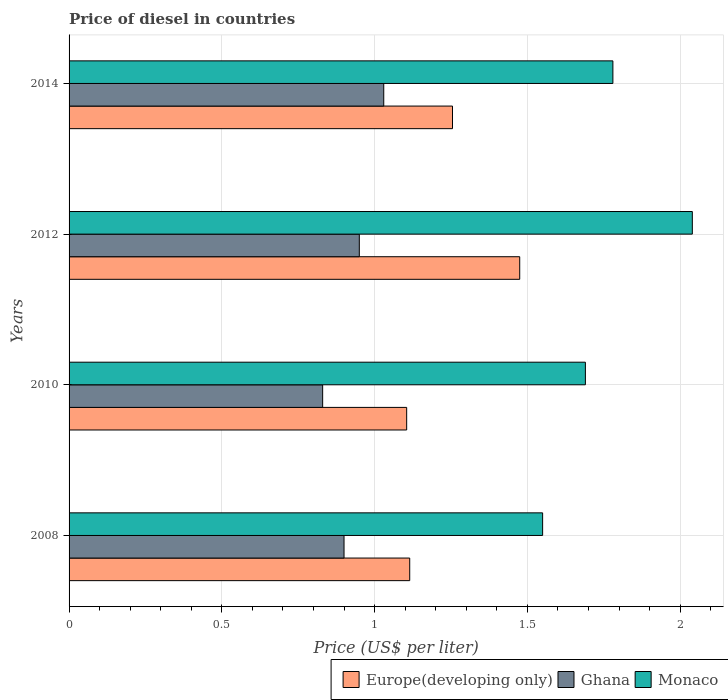How many bars are there on the 2nd tick from the bottom?
Make the answer very short. 3. What is the label of the 3rd group of bars from the top?
Keep it short and to the point. 2010. In how many cases, is the number of bars for a given year not equal to the number of legend labels?
Give a very brief answer. 0. What is the price of diesel in Monaco in 2008?
Offer a terse response. 1.55. Across all years, what is the maximum price of diesel in Monaco?
Offer a very short reply. 2.04. Across all years, what is the minimum price of diesel in Ghana?
Your answer should be very brief. 0.83. In which year was the price of diesel in Monaco maximum?
Offer a very short reply. 2012. What is the total price of diesel in Monaco in the graph?
Your answer should be very brief. 7.06. What is the difference between the price of diesel in Europe(developing only) in 2010 and that in 2012?
Offer a very short reply. -0.37. What is the difference between the price of diesel in Ghana in 2008 and the price of diesel in Monaco in 2012?
Provide a succinct answer. -1.14. What is the average price of diesel in Ghana per year?
Provide a short and direct response. 0.93. In the year 2012, what is the difference between the price of diesel in Monaco and price of diesel in Europe(developing only)?
Your answer should be very brief. 0.56. In how many years, is the price of diesel in Europe(developing only) greater than 1.2 US$?
Provide a succinct answer. 2. What is the ratio of the price of diesel in Ghana in 2010 to that in 2012?
Provide a short and direct response. 0.87. Is the price of diesel in Monaco in 2008 less than that in 2012?
Provide a short and direct response. Yes. What is the difference between the highest and the second highest price of diesel in Ghana?
Offer a very short reply. 0.08. What is the difference between the highest and the lowest price of diesel in Monaco?
Provide a succinct answer. 0.49. In how many years, is the price of diesel in Ghana greater than the average price of diesel in Ghana taken over all years?
Keep it short and to the point. 2. Is the sum of the price of diesel in Ghana in 2008 and 2014 greater than the maximum price of diesel in Monaco across all years?
Ensure brevity in your answer.  No. What does the 1st bar from the top in 2008 represents?
Ensure brevity in your answer.  Monaco. What does the 1st bar from the bottom in 2010 represents?
Offer a very short reply. Europe(developing only). How many bars are there?
Keep it short and to the point. 12. Are all the bars in the graph horizontal?
Give a very brief answer. Yes. What is the difference between two consecutive major ticks on the X-axis?
Offer a very short reply. 0.5. Does the graph contain any zero values?
Ensure brevity in your answer.  No. Does the graph contain grids?
Give a very brief answer. Yes. How are the legend labels stacked?
Make the answer very short. Horizontal. What is the title of the graph?
Give a very brief answer. Price of diesel in countries. Does "Somalia" appear as one of the legend labels in the graph?
Give a very brief answer. No. What is the label or title of the X-axis?
Your answer should be compact. Price (US$ per liter). What is the label or title of the Y-axis?
Keep it short and to the point. Years. What is the Price (US$ per liter) in Europe(developing only) in 2008?
Offer a very short reply. 1.11. What is the Price (US$ per liter) of Monaco in 2008?
Provide a short and direct response. 1.55. What is the Price (US$ per liter) of Europe(developing only) in 2010?
Your answer should be very brief. 1.1. What is the Price (US$ per liter) in Ghana in 2010?
Provide a short and direct response. 0.83. What is the Price (US$ per liter) of Monaco in 2010?
Ensure brevity in your answer.  1.69. What is the Price (US$ per liter) of Europe(developing only) in 2012?
Keep it short and to the point. 1.48. What is the Price (US$ per liter) of Ghana in 2012?
Provide a short and direct response. 0.95. What is the Price (US$ per liter) in Monaco in 2012?
Provide a succinct answer. 2.04. What is the Price (US$ per liter) in Europe(developing only) in 2014?
Offer a very short reply. 1.25. What is the Price (US$ per liter) of Monaco in 2014?
Provide a succinct answer. 1.78. Across all years, what is the maximum Price (US$ per liter) in Europe(developing only)?
Your response must be concise. 1.48. Across all years, what is the maximum Price (US$ per liter) in Ghana?
Provide a short and direct response. 1.03. Across all years, what is the maximum Price (US$ per liter) in Monaco?
Offer a very short reply. 2.04. Across all years, what is the minimum Price (US$ per liter) in Europe(developing only)?
Give a very brief answer. 1.1. Across all years, what is the minimum Price (US$ per liter) in Ghana?
Your answer should be very brief. 0.83. Across all years, what is the minimum Price (US$ per liter) in Monaco?
Your response must be concise. 1.55. What is the total Price (US$ per liter) of Europe(developing only) in the graph?
Your answer should be very brief. 4.95. What is the total Price (US$ per liter) of Ghana in the graph?
Offer a very short reply. 3.71. What is the total Price (US$ per liter) of Monaco in the graph?
Make the answer very short. 7.06. What is the difference between the Price (US$ per liter) of Europe(developing only) in 2008 and that in 2010?
Provide a succinct answer. 0.01. What is the difference between the Price (US$ per liter) of Ghana in 2008 and that in 2010?
Make the answer very short. 0.07. What is the difference between the Price (US$ per liter) in Monaco in 2008 and that in 2010?
Ensure brevity in your answer.  -0.14. What is the difference between the Price (US$ per liter) of Europe(developing only) in 2008 and that in 2012?
Give a very brief answer. -0.36. What is the difference between the Price (US$ per liter) in Ghana in 2008 and that in 2012?
Make the answer very short. -0.05. What is the difference between the Price (US$ per liter) of Monaco in 2008 and that in 2012?
Make the answer very short. -0.49. What is the difference between the Price (US$ per liter) in Europe(developing only) in 2008 and that in 2014?
Your answer should be compact. -0.14. What is the difference between the Price (US$ per liter) of Ghana in 2008 and that in 2014?
Give a very brief answer. -0.13. What is the difference between the Price (US$ per liter) in Monaco in 2008 and that in 2014?
Keep it short and to the point. -0.23. What is the difference between the Price (US$ per liter) in Europe(developing only) in 2010 and that in 2012?
Offer a terse response. -0.37. What is the difference between the Price (US$ per liter) in Ghana in 2010 and that in 2012?
Offer a very short reply. -0.12. What is the difference between the Price (US$ per liter) of Monaco in 2010 and that in 2012?
Make the answer very short. -0.35. What is the difference between the Price (US$ per liter) in Europe(developing only) in 2010 and that in 2014?
Your answer should be very brief. -0.15. What is the difference between the Price (US$ per liter) of Ghana in 2010 and that in 2014?
Your response must be concise. -0.2. What is the difference between the Price (US$ per liter) of Monaco in 2010 and that in 2014?
Your answer should be very brief. -0.09. What is the difference between the Price (US$ per liter) of Europe(developing only) in 2012 and that in 2014?
Offer a terse response. 0.22. What is the difference between the Price (US$ per liter) in Ghana in 2012 and that in 2014?
Offer a very short reply. -0.08. What is the difference between the Price (US$ per liter) of Monaco in 2012 and that in 2014?
Your response must be concise. 0.26. What is the difference between the Price (US$ per liter) of Europe(developing only) in 2008 and the Price (US$ per liter) of Ghana in 2010?
Your response must be concise. 0.28. What is the difference between the Price (US$ per liter) of Europe(developing only) in 2008 and the Price (US$ per liter) of Monaco in 2010?
Give a very brief answer. -0.57. What is the difference between the Price (US$ per liter) in Ghana in 2008 and the Price (US$ per liter) in Monaco in 2010?
Keep it short and to the point. -0.79. What is the difference between the Price (US$ per liter) of Europe(developing only) in 2008 and the Price (US$ per liter) of Ghana in 2012?
Your answer should be very brief. 0.17. What is the difference between the Price (US$ per liter) in Europe(developing only) in 2008 and the Price (US$ per liter) in Monaco in 2012?
Your answer should be compact. -0.93. What is the difference between the Price (US$ per liter) in Ghana in 2008 and the Price (US$ per liter) in Monaco in 2012?
Offer a terse response. -1.14. What is the difference between the Price (US$ per liter) of Europe(developing only) in 2008 and the Price (US$ per liter) of Ghana in 2014?
Provide a succinct answer. 0.09. What is the difference between the Price (US$ per liter) of Europe(developing only) in 2008 and the Price (US$ per liter) of Monaco in 2014?
Your answer should be very brief. -0.67. What is the difference between the Price (US$ per liter) in Ghana in 2008 and the Price (US$ per liter) in Monaco in 2014?
Give a very brief answer. -0.88. What is the difference between the Price (US$ per liter) of Europe(developing only) in 2010 and the Price (US$ per liter) of Ghana in 2012?
Keep it short and to the point. 0.15. What is the difference between the Price (US$ per liter) in Europe(developing only) in 2010 and the Price (US$ per liter) in Monaco in 2012?
Give a very brief answer. -0.94. What is the difference between the Price (US$ per liter) of Ghana in 2010 and the Price (US$ per liter) of Monaco in 2012?
Offer a terse response. -1.21. What is the difference between the Price (US$ per liter) of Europe(developing only) in 2010 and the Price (US$ per liter) of Ghana in 2014?
Your answer should be very brief. 0.07. What is the difference between the Price (US$ per liter) in Europe(developing only) in 2010 and the Price (US$ per liter) in Monaco in 2014?
Provide a short and direct response. -0.68. What is the difference between the Price (US$ per liter) of Ghana in 2010 and the Price (US$ per liter) of Monaco in 2014?
Your response must be concise. -0.95. What is the difference between the Price (US$ per liter) of Europe(developing only) in 2012 and the Price (US$ per liter) of Ghana in 2014?
Provide a succinct answer. 0.45. What is the difference between the Price (US$ per liter) in Europe(developing only) in 2012 and the Price (US$ per liter) in Monaco in 2014?
Offer a terse response. -0.3. What is the difference between the Price (US$ per liter) in Ghana in 2012 and the Price (US$ per liter) in Monaco in 2014?
Your answer should be compact. -0.83. What is the average Price (US$ per liter) of Europe(developing only) per year?
Your answer should be compact. 1.24. What is the average Price (US$ per liter) in Ghana per year?
Your response must be concise. 0.93. What is the average Price (US$ per liter) of Monaco per year?
Offer a terse response. 1.76. In the year 2008, what is the difference between the Price (US$ per liter) of Europe(developing only) and Price (US$ per liter) of Ghana?
Give a very brief answer. 0.21. In the year 2008, what is the difference between the Price (US$ per liter) of Europe(developing only) and Price (US$ per liter) of Monaco?
Give a very brief answer. -0.43. In the year 2008, what is the difference between the Price (US$ per liter) of Ghana and Price (US$ per liter) of Monaco?
Your answer should be very brief. -0.65. In the year 2010, what is the difference between the Price (US$ per liter) of Europe(developing only) and Price (US$ per liter) of Ghana?
Provide a short and direct response. 0.28. In the year 2010, what is the difference between the Price (US$ per liter) in Europe(developing only) and Price (US$ per liter) in Monaco?
Offer a terse response. -0.58. In the year 2010, what is the difference between the Price (US$ per liter) in Ghana and Price (US$ per liter) in Monaco?
Provide a short and direct response. -0.86. In the year 2012, what is the difference between the Price (US$ per liter) of Europe(developing only) and Price (US$ per liter) of Ghana?
Give a very brief answer. 0.53. In the year 2012, what is the difference between the Price (US$ per liter) of Europe(developing only) and Price (US$ per liter) of Monaco?
Ensure brevity in your answer.  -0.56. In the year 2012, what is the difference between the Price (US$ per liter) of Ghana and Price (US$ per liter) of Monaco?
Provide a short and direct response. -1.09. In the year 2014, what is the difference between the Price (US$ per liter) in Europe(developing only) and Price (US$ per liter) in Ghana?
Your response must be concise. 0.23. In the year 2014, what is the difference between the Price (US$ per liter) in Europe(developing only) and Price (US$ per liter) in Monaco?
Your answer should be very brief. -0.53. In the year 2014, what is the difference between the Price (US$ per liter) in Ghana and Price (US$ per liter) in Monaco?
Your response must be concise. -0.75. What is the ratio of the Price (US$ per liter) of Ghana in 2008 to that in 2010?
Give a very brief answer. 1.08. What is the ratio of the Price (US$ per liter) in Monaco in 2008 to that in 2010?
Your answer should be compact. 0.92. What is the ratio of the Price (US$ per liter) in Europe(developing only) in 2008 to that in 2012?
Make the answer very short. 0.76. What is the ratio of the Price (US$ per liter) in Monaco in 2008 to that in 2012?
Your answer should be compact. 0.76. What is the ratio of the Price (US$ per liter) in Europe(developing only) in 2008 to that in 2014?
Ensure brevity in your answer.  0.89. What is the ratio of the Price (US$ per liter) of Ghana in 2008 to that in 2014?
Give a very brief answer. 0.87. What is the ratio of the Price (US$ per liter) in Monaco in 2008 to that in 2014?
Offer a very short reply. 0.87. What is the ratio of the Price (US$ per liter) in Europe(developing only) in 2010 to that in 2012?
Offer a very short reply. 0.75. What is the ratio of the Price (US$ per liter) in Ghana in 2010 to that in 2012?
Provide a short and direct response. 0.87. What is the ratio of the Price (US$ per liter) in Monaco in 2010 to that in 2012?
Give a very brief answer. 0.83. What is the ratio of the Price (US$ per liter) of Europe(developing only) in 2010 to that in 2014?
Provide a short and direct response. 0.88. What is the ratio of the Price (US$ per liter) of Ghana in 2010 to that in 2014?
Make the answer very short. 0.81. What is the ratio of the Price (US$ per liter) in Monaco in 2010 to that in 2014?
Offer a terse response. 0.95. What is the ratio of the Price (US$ per liter) in Europe(developing only) in 2012 to that in 2014?
Make the answer very short. 1.18. What is the ratio of the Price (US$ per liter) of Ghana in 2012 to that in 2014?
Ensure brevity in your answer.  0.92. What is the ratio of the Price (US$ per liter) in Monaco in 2012 to that in 2014?
Ensure brevity in your answer.  1.15. What is the difference between the highest and the second highest Price (US$ per liter) in Europe(developing only)?
Give a very brief answer. 0.22. What is the difference between the highest and the second highest Price (US$ per liter) of Monaco?
Make the answer very short. 0.26. What is the difference between the highest and the lowest Price (US$ per liter) in Europe(developing only)?
Provide a succinct answer. 0.37. What is the difference between the highest and the lowest Price (US$ per liter) of Ghana?
Your answer should be very brief. 0.2. What is the difference between the highest and the lowest Price (US$ per liter) in Monaco?
Ensure brevity in your answer.  0.49. 